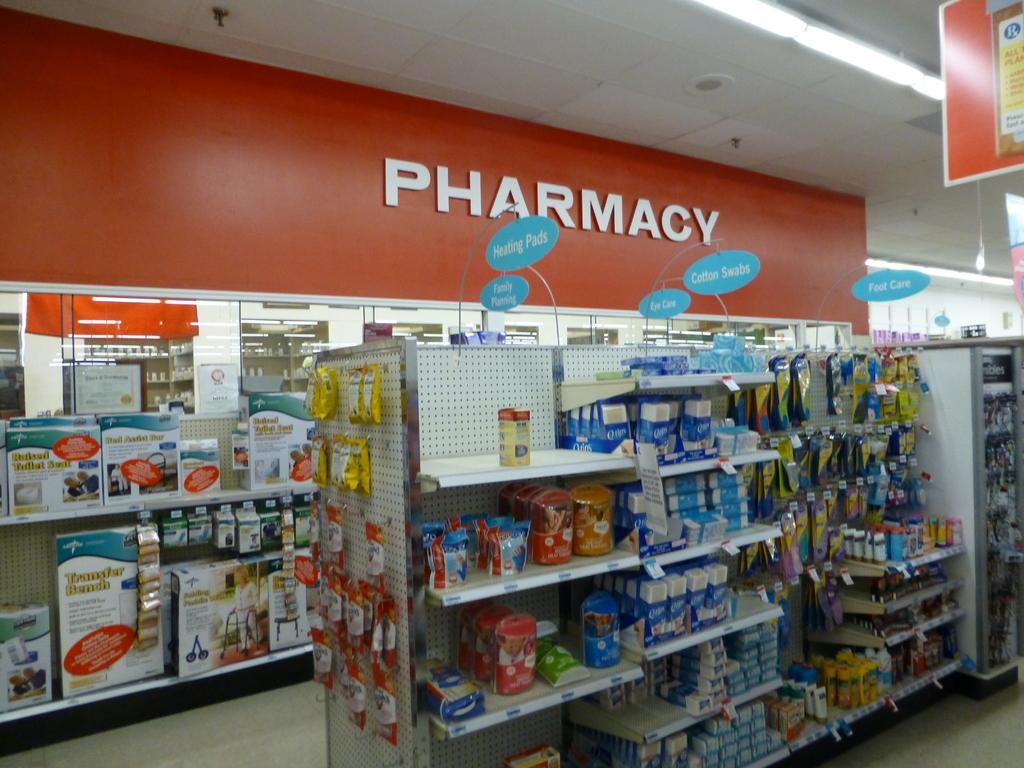Please provide a concise description of this image. In this image we can see a group of objects, containers, boxes and some covers which are placed on the racks. We can also see some boards with text on them, pillars and a roof with some ceiling lights. 